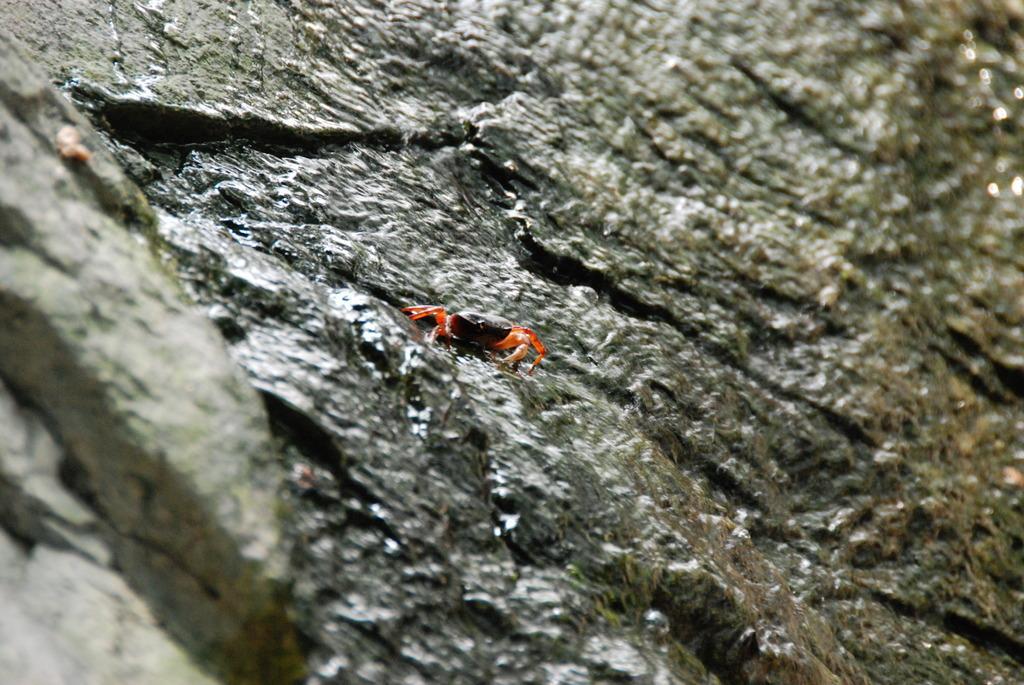How would you summarize this image in a sentence or two? In this image we can see the insect on the rock. 